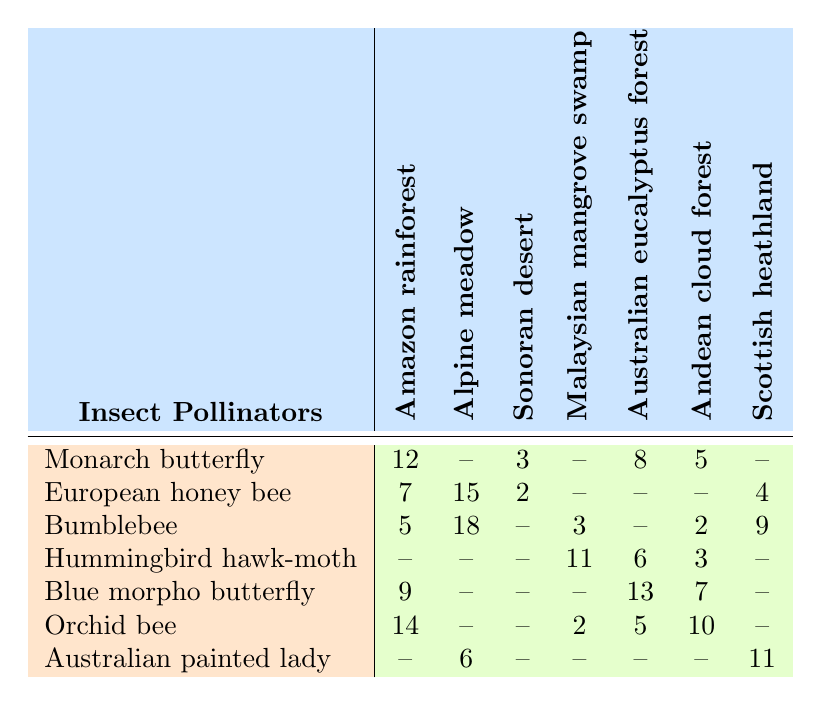What is the occurrence of the Bumblebee in the Alpine meadow? Referring to the table, the occurrence of the Bumblebee in the Alpine meadow column shows a value of 18.
Answer: 18 Which insect pollinator has the highest occurrence in the Amazon rainforest? The table shows Monarch butterfly with an occurrence of 12, which is the highest among all insect pollinators listed.
Answer: Monarch butterfly How many occurrences of Blue morpho butterfly are found in the Australian eucalyptus forest? In the Australian eucalyptus forest column, the occurrence of Blue morpho butterfly is 13.
Answer: 13 Is there any insect pollinator that is not present in the Sonoran desert? The Bumblebee shows "--" indicating no occurrences in the Sonoran desert. Therefore, it is true that a pollinator is absent.
Answer: Yes What is the total occurrence of the Hummingbird hawk-moth across all habitats? The Hummingbird hawk-moth has occurrences of 0, 0, 0, 11, 6, 3, and 0 across the habitats. Summing these gives 0 + 0 + 0 + 11 + 6 + 3 + 0 = 20.
Answer: 20 Which plant habitat has the least occurrences of insect pollinators? By examining the table, the Sonoran desert has a minimum total occurrence since it only has a few pollinators documented, with the highest value being 3.
Answer: Sonoran desert What is the average occurrence of insect pollinators in the Andean cloud forest? The occurrences in the Andean cloud forest are 5, 0, 2, 3, 7, and 0. Adding these, we get 5 + 0 + 2 + 3 + 7 + 0 = 17; there are 6 data points, so the average is 17/6 ≈ 2.83.
Answer: Approximately 2.83 Which insect pollinator has zero occurrences in the Malaysian mangrove swamp? Observing the table, the Monarch butterfly and Blue morpho butterfly both show "--" in the Malaysian mangrove swamp, indicating zero occurrences.
Answer: Monarch butterfly and Blue morpho butterfly What is the total number of occurrences for the Australian painted lady across all habitats? The occurrences for Australian painted lady are shown as 0 + 6 + 0 + 0 + 0 + 0 + 11, totaling to 17.
Answer: 17 Which insect pollinator has the lowest overall presence across the seven plant habitats? Upon examining all occurrences, the Hummingbird hawk-moth has the lowest total presence with only 20 occurrences across habitats.
Answer: Hummingbird hawk-moth 